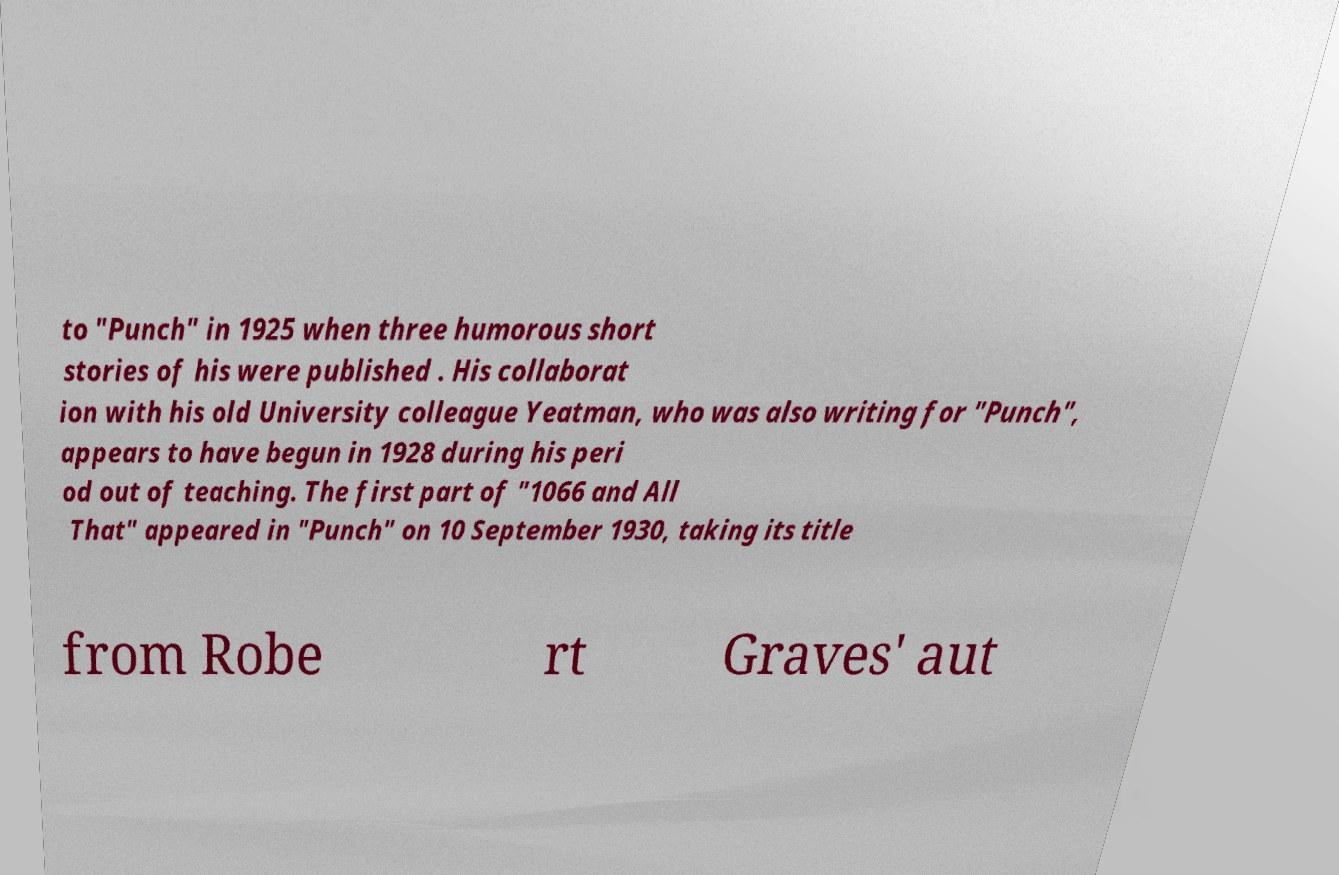I need the written content from this picture converted into text. Can you do that? to "Punch" in 1925 when three humorous short stories of his were published . His collaborat ion with his old University colleague Yeatman, who was also writing for "Punch", appears to have begun in 1928 during his peri od out of teaching. The first part of "1066 and All That" appeared in "Punch" on 10 September 1930, taking its title from Robe rt Graves' aut 